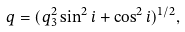<formula> <loc_0><loc_0><loc_500><loc_500>q = ( q _ { 3 } ^ { 2 } \sin ^ { 2 } i + \cos ^ { 2 } i ) ^ { 1 / 2 } ,</formula> 